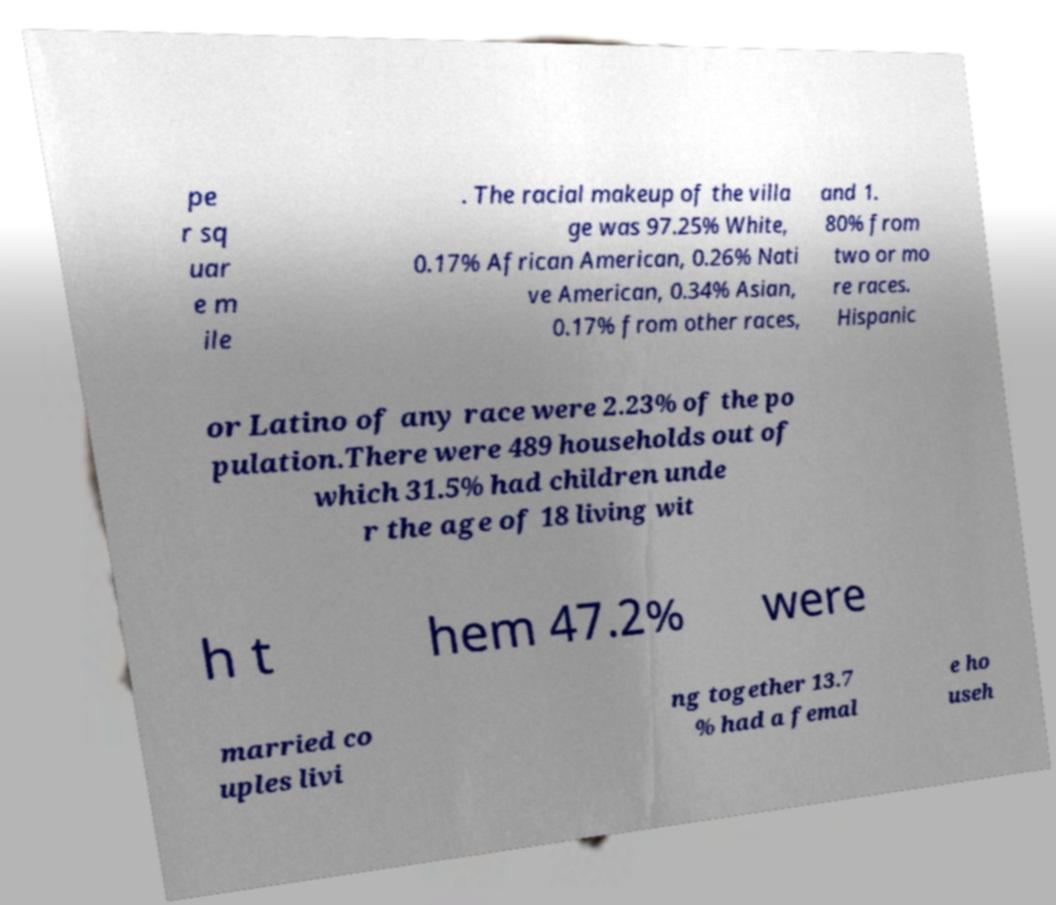Could you extract and type out the text from this image? pe r sq uar e m ile . The racial makeup of the villa ge was 97.25% White, 0.17% African American, 0.26% Nati ve American, 0.34% Asian, 0.17% from other races, and 1. 80% from two or mo re races. Hispanic or Latino of any race were 2.23% of the po pulation.There were 489 households out of which 31.5% had children unde r the age of 18 living wit h t hem 47.2% were married co uples livi ng together 13.7 % had a femal e ho useh 